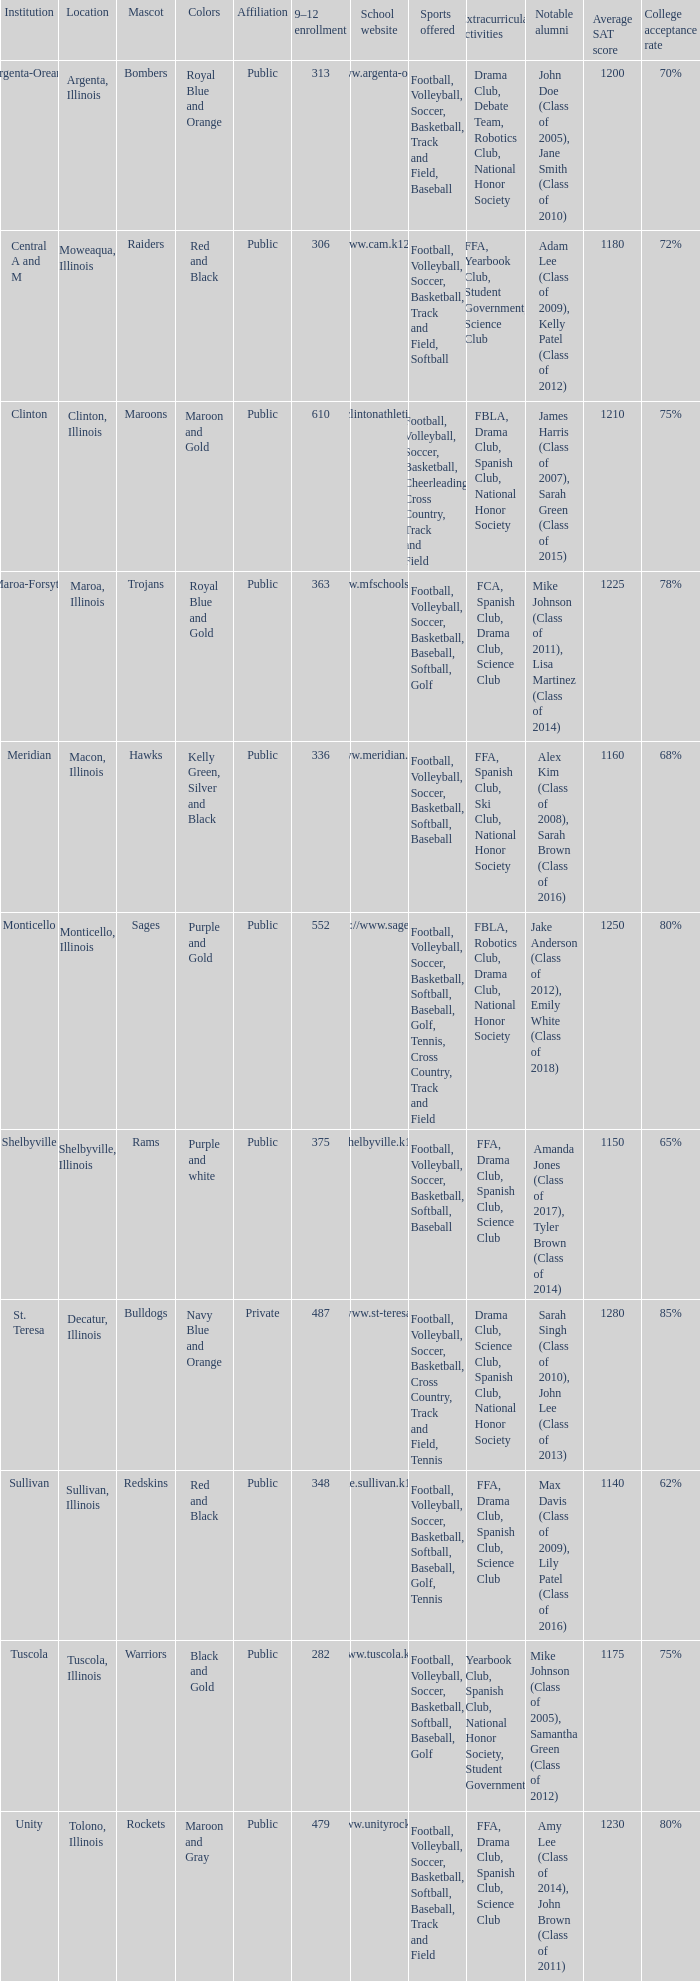What location has 363 students enrolled in the 9th to 12th grades? Maroa, Illinois. 